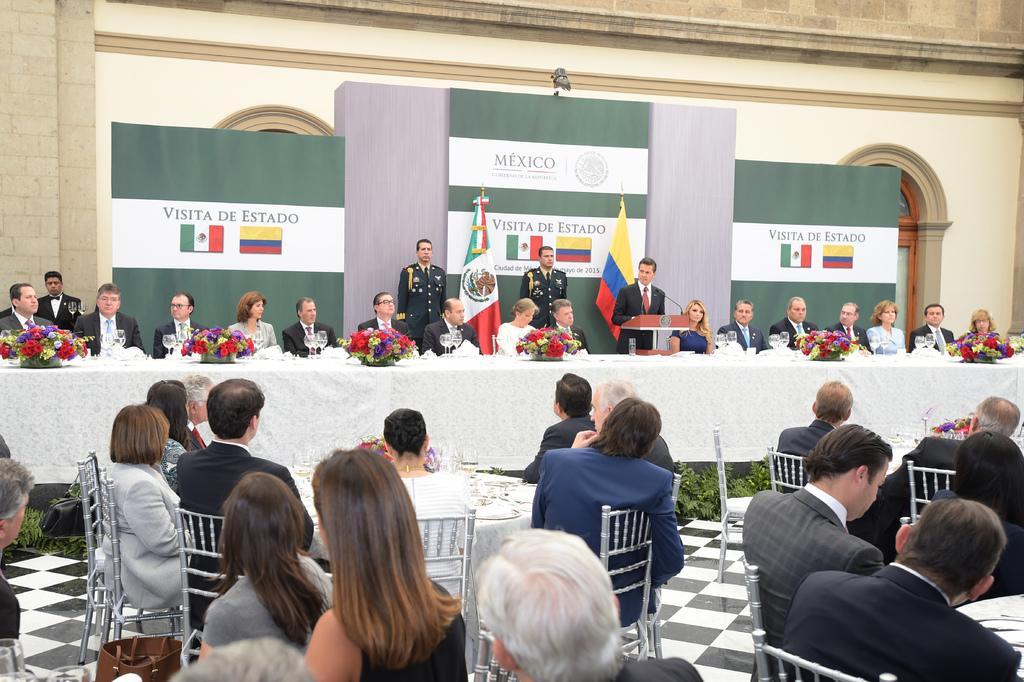Describe this image in one or two sentences. In this image I can see group of people sitting on the chairs. I can see glasses,few colorful flower on the table. I can see a podium,board and flags. I can see building and glass windows. 